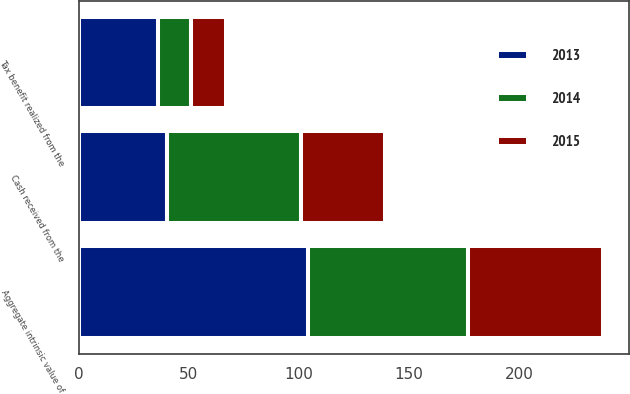<chart> <loc_0><loc_0><loc_500><loc_500><stacked_bar_chart><ecel><fcel>Aggregate intrinsic value of<fcel>Cash received from the<fcel>Tax benefit realized from the<nl><fcel>2013<fcel>104<fcel>40<fcel>36<nl><fcel>2015<fcel>61<fcel>38<fcel>16<nl><fcel>2014<fcel>73<fcel>61<fcel>15<nl></chart> 